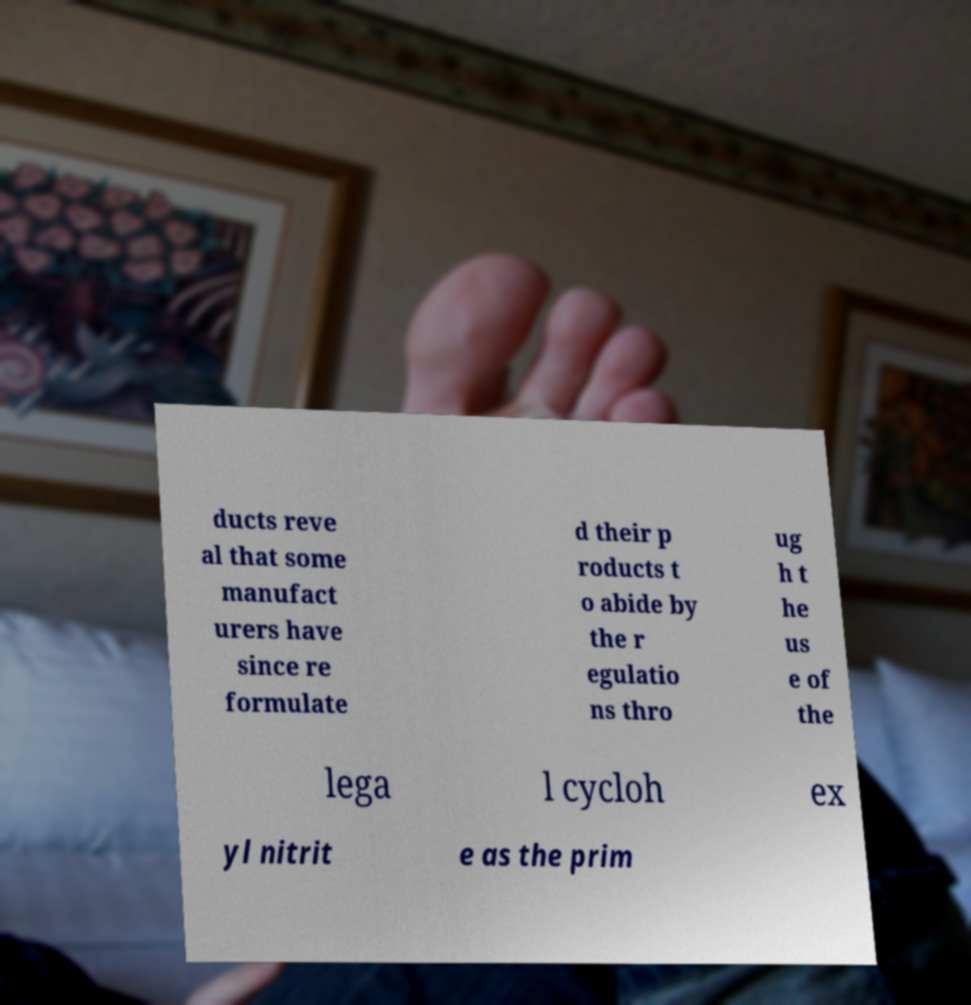Please identify and transcribe the text found in this image. ducts reve al that some manufact urers have since re formulate d their p roducts t o abide by the r egulatio ns thro ug h t he us e of the lega l cycloh ex yl nitrit e as the prim 